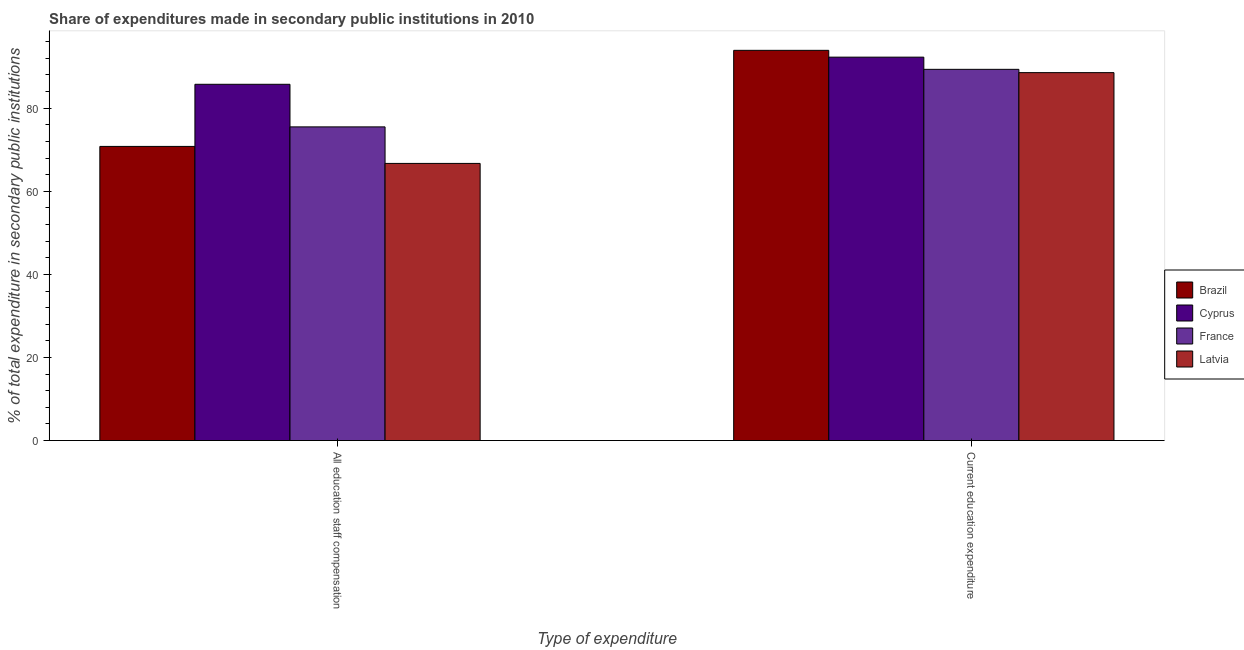How many groups of bars are there?
Your answer should be compact. 2. Are the number of bars per tick equal to the number of legend labels?
Provide a succinct answer. Yes. Are the number of bars on each tick of the X-axis equal?
Provide a short and direct response. Yes. How many bars are there on the 1st tick from the left?
Keep it short and to the point. 4. What is the label of the 1st group of bars from the left?
Make the answer very short. All education staff compensation. What is the expenditure in education in Cyprus?
Provide a succinct answer. 92.3. Across all countries, what is the maximum expenditure in staff compensation?
Provide a short and direct response. 85.76. Across all countries, what is the minimum expenditure in staff compensation?
Provide a succinct answer. 66.72. In which country was the expenditure in staff compensation maximum?
Your response must be concise. Cyprus. In which country was the expenditure in education minimum?
Keep it short and to the point. Latvia. What is the total expenditure in staff compensation in the graph?
Your response must be concise. 298.8. What is the difference between the expenditure in education in Brazil and that in France?
Make the answer very short. 4.57. What is the difference between the expenditure in education in Latvia and the expenditure in staff compensation in Brazil?
Provide a succinct answer. 17.76. What is the average expenditure in education per country?
Keep it short and to the point. 91.04. What is the difference between the expenditure in education and expenditure in staff compensation in Brazil?
Make the answer very short. 23.13. In how many countries, is the expenditure in education greater than 92 %?
Your response must be concise. 2. What is the ratio of the expenditure in education in France to that in Brazil?
Make the answer very short. 0.95. In how many countries, is the expenditure in staff compensation greater than the average expenditure in staff compensation taken over all countries?
Provide a succinct answer. 2. What does the 4th bar from the left in All education staff compensation represents?
Ensure brevity in your answer.  Latvia. What is the difference between two consecutive major ticks on the Y-axis?
Provide a succinct answer. 20. Are the values on the major ticks of Y-axis written in scientific E-notation?
Your answer should be very brief. No. Does the graph contain any zero values?
Your response must be concise. No. Does the graph contain grids?
Provide a short and direct response. No. Where does the legend appear in the graph?
Your answer should be compact. Center right. How many legend labels are there?
Ensure brevity in your answer.  4. What is the title of the graph?
Offer a very short reply. Share of expenditures made in secondary public institutions in 2010. Does "Vanuatu" appear as one of the legend labels in the graph?
Your answer should be compact. No. What is the label or title of the X-axis?
Give a very brief answer. Type of expenditure. What is the label or title of the Y-axis?
Make the answer very short. % of total expenditure in secondary public institutions. What is the % of total expenditure in secondary public institutions in Brazil in All education staff compensation?
Offer a very short reply. 70.81. What is the % of total expenditure in secondary public institutions of Cyprus in All education staff compensation?
Your answer should be very brief. 85.76. What is the % of total expenditure in secondary public institutions in France in All education staff compensation?
Ensure brevity in your answer.  75.51. What is the % of total expenditure in secondary public institutions in Latvia in All education staff compensation?
Provide a short and direct response. 66.72. What is the % of total expenditure in secondary public institutions of Brazil in Current education expenditure?
Your answer should be compact. 93.94. What is the % of total expenditure in secondary public institutions of Cyprus in Current education expenditure?
Provide a short and direct response. 92.3. What is the % of total expenditure in secondary public institutions of France in Current education expenditure?
Provide a short and direct response. 89.36. What is the % of total expenditure in secondary public institutions of Latvia in Current education expenditure?
Provide a short and direct response. 88.57. Across all Type of expenditure, what is the maximum % of total expenditure in secondary public institutions of Brazil?
Keep it short and to the point. 93.94. Across all Type of expenditure, what is the maximum % of total expenditure in secondary public institutions in Cyprus?
Provide a succinct answer. 92.3. Across all Type of expenditure, what is the maximum % of total expenditure in secondary public institutions of France?
Keep it short and to the point. 89.36. Across all Type of expenditure, what is the maximum % of total expenditure in secondary public institutions of Latvia?
Offer a very short reply. 88.57. Across all Type of expenditure, what is the minimum % of total expenditure in secondary public institutions in Brazil?
Provide a short and direct response. 70.81. Across all Type of expenditure, what is the minimum % of total expenditure in secondary public institutions of Cyprus?
Offer a terse response. 85.76. Across all Type of expenditure, what is the minimum % of total expenditure in secondary public institutions in France?
Give a very brief answer. 75.51. Across all Type of expenditure, what is the minimum % of total expenditure in secondary public institutions in Latvia?
Make the answer very short. 66.72. What is the total % of total expenditure in secondary public institutions of Brazil in the graph?
Keep it short and to the point. 164.75. What is the total % of total expenditure in secondary public institutions of Cyprus in the graph?
Offer a terse response. 178.06. What is the total % of total expenditure in secondary public institutions in France in the graph?
Provide a short and direct response. 164.87. What is the total % of total expenditure in secondary public institutions of Latvia in the graph?
Offer a terse response. 155.29. What is the difference between the % of total expenditure in secondary public institutions of Brazil in All education staff compensation and that in Current education expenditure?
Keep it short and to the point. -23.13. What is the difference between the % of total expenditure in secondary public institutions in Cyprus in All education staff compensation and that in Current education expenditure?
Provide a succinct answer. -6.53. What is the difference between the % of total expenditure in secondary public institutions in France in All education staff compensation and that in Current education expenditure?
Ensure brevity in your answer.  -13.85. What is the difference between the % of total expenditure in secondary public institutions in Latvia in All education staff compensation and that in Current education expenditure?
Offer a terse response. -21.85. What is the difference between the % of total expenditure in secondary public institutions of Brazil in All education staff compensation and the % of total expenditure in secondary public institutions of Cyprus in Current education expenditure?
Ensure brevity in your answer.  -21.49. What is the difference between the % of total expenditure in secondary public institutions in Brazil in All education staff compensation and the % of total expenditure in secondary public institutions in France in Current education expenditure?
Your answer should be compact. -18.55. What is the difference between the % of total expenditure in secondary public institutions in Brazil in All education staff compensation and the % of total expenditure in secondary public institutions in Latvia in Current education expenditure?
Give a very brief answer. -17.76. What is the difference between the % of total expenditure in secondary public institutions in Cyprus in All education staff compensation and the % of total expenditure in secondary public institutions in France in Current education expenditure?
Make the answer very short. -3.6. What is the difference between the % of total expenditure in secondary public institutions of Cyprus in All education staff compensation and the % of total expenditure in secondary public institutions of Latvia in Current education expenditure?
Your answer should be very brief. -2.81. What is the difference between the % of total expenditure in secondary public institutions of France in All education staff compensation and the % of total expenditure in secondary public institutions of Latvia in Current education expenditure?
Give a very brief answer. -13.06. What is the average % of total expenditure in secondary public institutions in Brazil per Type of expenditure?
Your answer should be compact. 82.37. What is the average % of total expenditure in secondary public institutions in Cyprus per Type of expenditure?
Your answer should be compact. 89.03. What is the average % of total expenditure in secondary public institutions of France per Type of expenditure?
Give a very brief answer. 82.44. What is the average % of total expenditure in secondary public institutions of Latvia per Type of expenditure?
Provide a succinct answer. 77.64. What is the difference between the % of total expenditure in secondary public institutions of Brazil and % of total expenditure in secondary public institutions of Cyprus in All education staff compensation?
Ensure brevity in your answer.  -14.95. What is the difference between the % of total expenditure in secondary public institutions of Brazil and % of total expenditure in secondary public institutions of France in All education staff compensation?
Your answer should be compact. -4.7. What is the difference between the % of total expenditure in secondary public institutions in Brazil and % of total expenditure in secondary public institutions in Latvia in All education staff compensation?
Make the answer very short. 4.09. What is the difference between the % of total expenditure in secondary public institutions in Cyprus and % of total expenditure in secondary public institutions in France in All education staff compensation?
Your response must be concise. 10.25. What is the difference between the % of total expenditure in secondary public institutions of Cyprus and % of total expenditure in secondary public institutions of Latvia in All education staff compensation?
Your answer should be very brief. 19.05. What is the difference between the % of total expenditure in secondary public institutions in France and % of total expenditure in secondary public institutions in Latvia in All education staff compensation?
Keep it short and to the point. 8.79. What is the difference between the % of total expenditure in secondary public institutions in Brazil and % of total expenditure in secondary public institutions in Cyprus in Current education expenditure?
Provide a short and direct response. 1.64. What is the difference between the % of total expenditure in secondary public institutions in Brazil and % of total expenditure in secondary public institutions in France in Current education expenditure?
Your answer should be compact. 4.57. What is the difference between the % of total expenditure in secondary public institutions in Brazil and % of total expenditure in secondary public institutions in Latvia in Current education expenditure?
Offer a very short reply. 5.37. What is the difference between the % of total expenditure in secondary public institutions of Cyprus and % of total expenditure in secondary public institutions of France in Current education expenditure?
Provide a succinct answer. 2.93. What is the difference between the % of total expenditure in secondary public institutions of Cyprus and % of total expenditure in secondary public institutions of Latvia in Current education expenditure?
Provide a short and direct response. 3.73. What is the difference between the % of total expenditure in secondary public institutions in France and % of total expenditure in secondary public institutions in Latvia in Current education expenditure?
Your response must be concise. 0.79. What is the ratio of the % of total expenditure in secondary public institutions of Brazil in All education staff compensation to that in Current education expenditure?
Your response must be concise. 0.75. What is the ratio of the % of total expenditure in secondary public institutions in Cyprus in All education staff compensation to that in Current education expenditure?
Offer a terse response. 0.93. What is the ratio of the % of total expenditure in secondary public institutions in France in All education staff compensation to that in Current education expenditure?
Make the answer very short. 0.84. What is the ratio of the % of total expenditure in secondary public institutions of Latvia in All education staff compensation to that in Current education expenditure?
Keep it short and to the point. 0.75. What is the difference between the highest and the second highest % of total expenditure in secondary public institutions of Brazil?
Your answer should be very brief. 23.13. What is the difference between the highest and the second highest % of total expenditure in secondary public institutions of Cyprus?
Your response must be concise. 6.53. What is the difference between the highest and the second highest % of total expenditure in secondary public institutions of France?
Give a very brief answer. 13.85. What is the difference between the highest and the second highest % of total expenditure in secondary public institutions in Latvia?
Provide a short and direct response. 21.85. What is the difference between the highest and the lowest % of total expenditure in secondary public institutions in Brazil?
Offer a very short reply. 23.13. What is the difference between the highest and the lowest % of total expenditure in secondary public institutions in Cyprus?
Keep it short and to the point. 6.53. What is the difference between the highest and the lowest % of total expenditure in secondary public institutions of France?
Your response must be concise. 13.85. What is the difference between the highest and the lowest % of total expenditure in secondary public institutions of Latvia?
Keep it short and to the point. 21.85. 